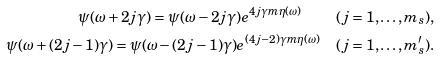Convert formula to latex. <formula><loc_0><loc_0><loc_500><loc_500>\psi ( \omega + 2 j \gamma ) = \psi ( \omega - 2 j \gamma ) e ^ { 4 j \gamma m \eta ( \omega ) } \quad ( j = 1 , \dots , m _ { s } ) , \\ \psi ( \omega + ( 2 j - 1 ) \gamma ) = \psi ( \omega - ( 2 j - 1 ) \gamma ) e ^ { ( 4 j - 2 ) \gamma m \eta ( \omega ) } \quad ( j = 1 , \dots , m ^ { \prime } _ { s } ) .</formula> 